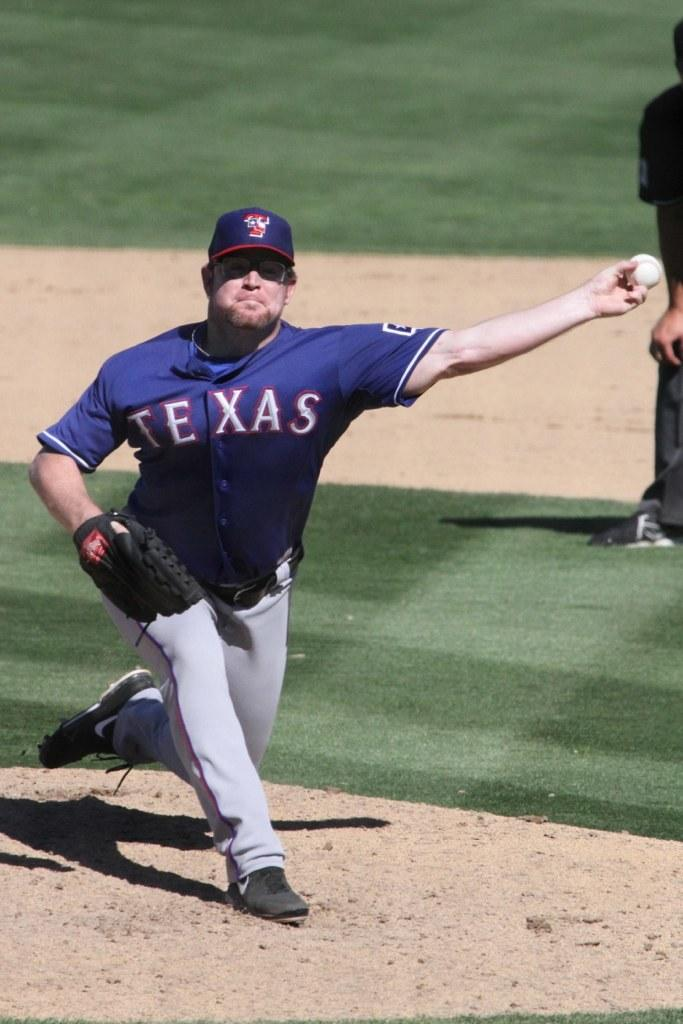<image>
Summarize the visual content of the image. Man wearing a Texas jersey pitching the ball. 